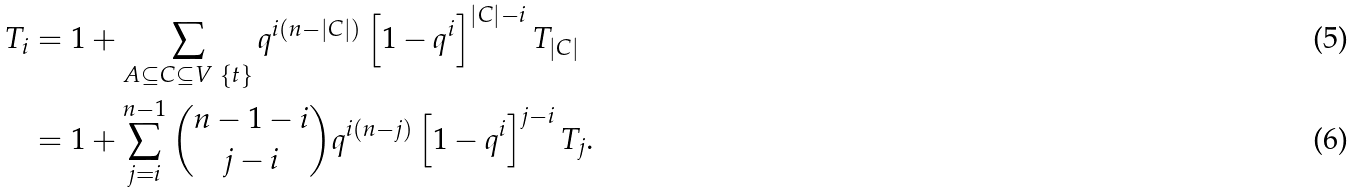Convert formula to latex. <formula><loc_0><loc_0><loc_500><loc_500>T _ { i } & = 1 + \sum _ { A \subseteq C \subseteq V \ \{ t \} } q ^ { i ( n - | C | ) } \left [ 1 - q ^ { i } \right ] ^ { | C | - i } T _ { | C | } \\ & = 1 + \sum _ { j = i } ^ { n - 1 } \binom { n - 1 - i } { j - i } q ^ { i ( n - j ) } \left [ 1 - q ^ { i } \right ] ^ { j - i } T _ { j } .</formula> 